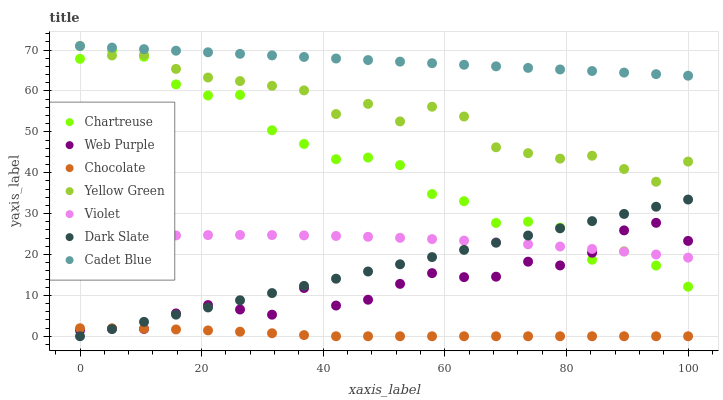Does Chocolate have the minimum area under the curve?
Answer yes or no. Yes. Does Cadet Blue have the maximum area under the curve?
Answer yes or no. Yes. Does Yellow Green have the minimum area under the curve?
Answer yes or no. No. Does Yellow Green have the maximum area under the curve?
Answer yes or no. No. Is Dark Slate the smoothest?
Answer yes or no. Yes. Is Chartreuse the roughest?
Answer yes or no. Yes. Is Yellow Green the smoothest?
Answer yes or no. No. Is Yellow Green the roughest?
Answer yes or no. No. Does Chocolate have the lowest value?
Answer yes or no. Yes. Does Yellow Green have the lowest value?
Answer yes or no. No. Does Yellow Green have the highest value?
Answer yes or no. Yes. Does Web Purple have the highest value?
Answer yes or no. No. Is Chocolate less than Chartreuse?
Answer yes or no. Yes. Is Cadet Blue greater than Violet?
Answer yes or no. Yes. Does Violet intersect Dark Slate?
Answer yes or no. Yes. Is Violet less than Dark Slate?
Answer yes or no. No. Is Violet greater than Dark Slate?
Answer yes or no. No. Does Chocolate intersect Chartreuse?
Answer yes or no. No. 